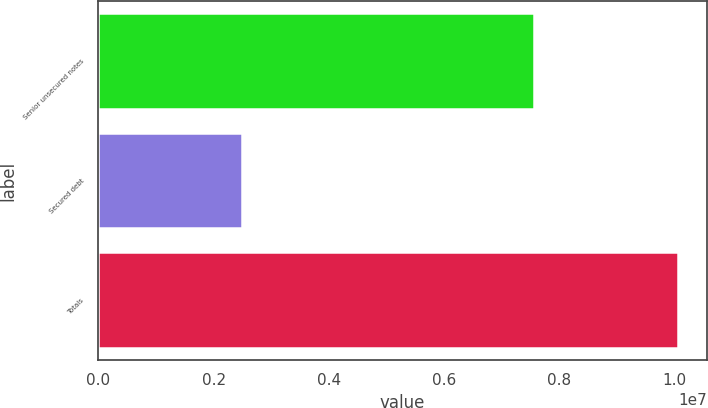Convert chart to OTSL. <chart><loc_0><loc_0><loc_500><loc_500><bar_chart><fcel>Senior unsecured notes<fcel>Secured debt<fcel>Totals<nl><fcel>7.56883e+06<fcel>2.48928e+06<fcel>1.00581e+07<nl></chart> 